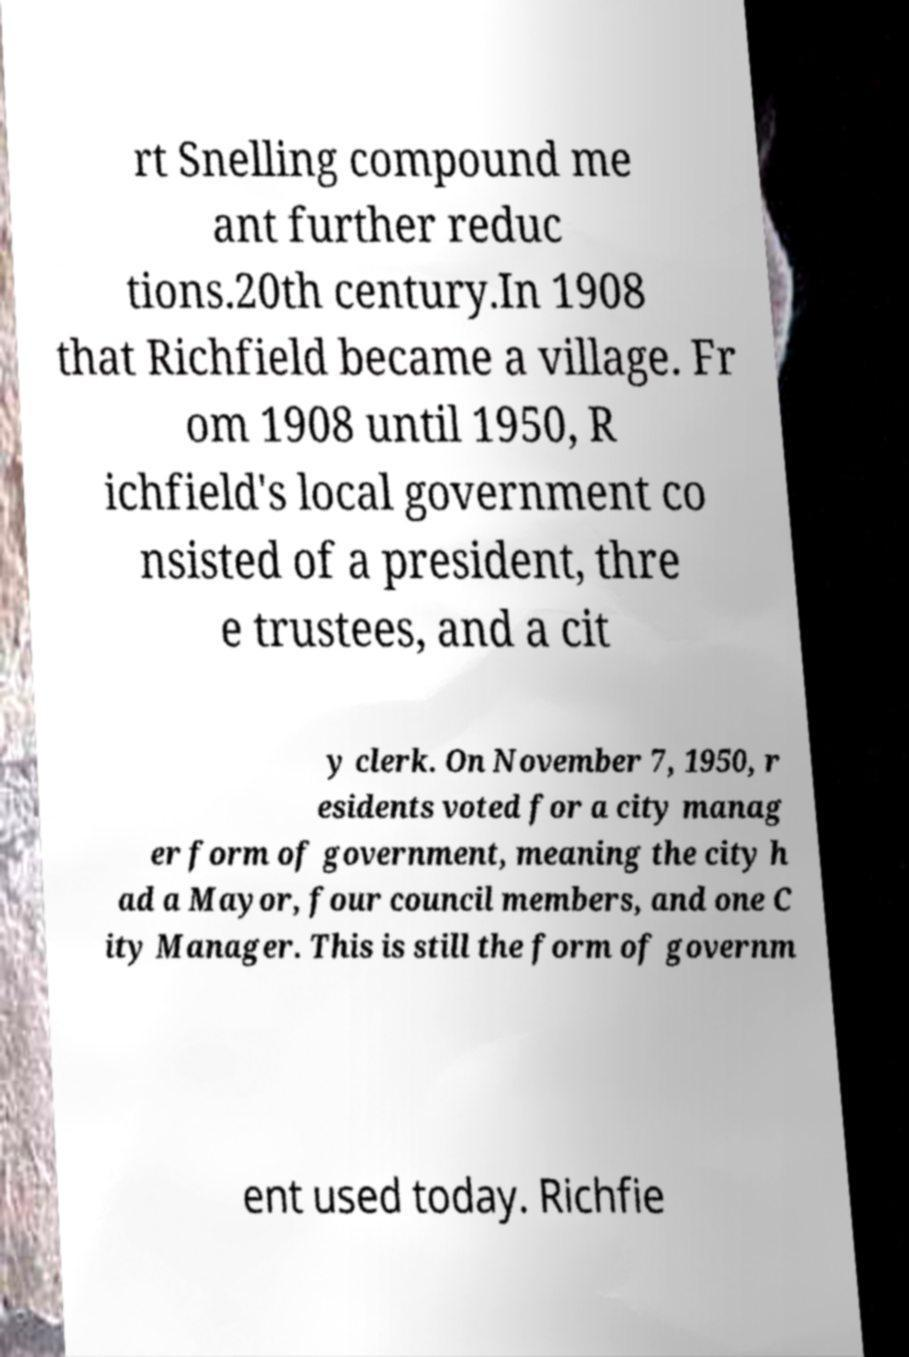Could you assist in decoding the text presented in this image and type it out clearly? rt Snelling compound me ant further reduc tions.20th century.In 1908 that Richfield became a village. Fr om 1908 until 1950, R ichfield's local government co nsisted of a president, thre e trustees, and a cit y clerk. On November 7, 1950, r esidents voted for a city manag er form of government, meaning the city h ad a Mayor, four council members, and one C ity Manager. This is still the form of governm ent used today. Richfie 